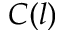Convert formula to latex. <formula><loc_0><loc_0><loc_500><loc_500>C ( l )</formula> 